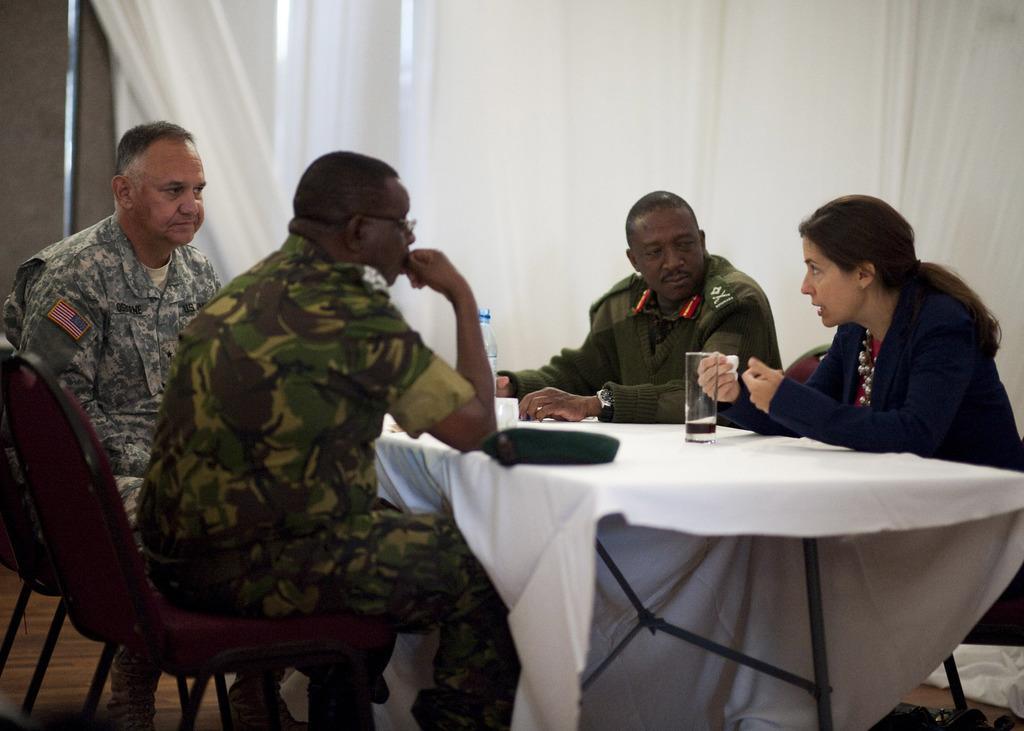Could you give a brief overview of what you see in this image? There are three men and one women sitting on the chairs. This is a table covered with white cloth. A water bottle,tumbler and some other objects are placed on the table. At background I can see a white cloth hanging. 